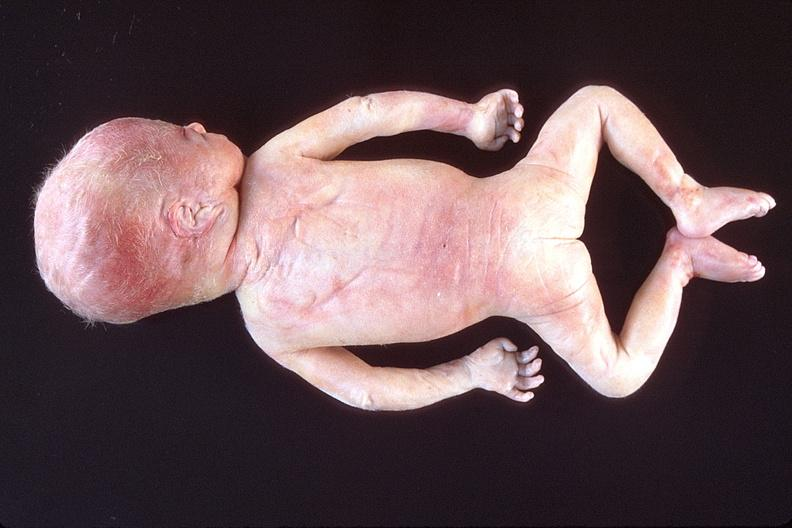what does this image show?
Answer the question using a single word or phrase. Hyaline membrane disease 